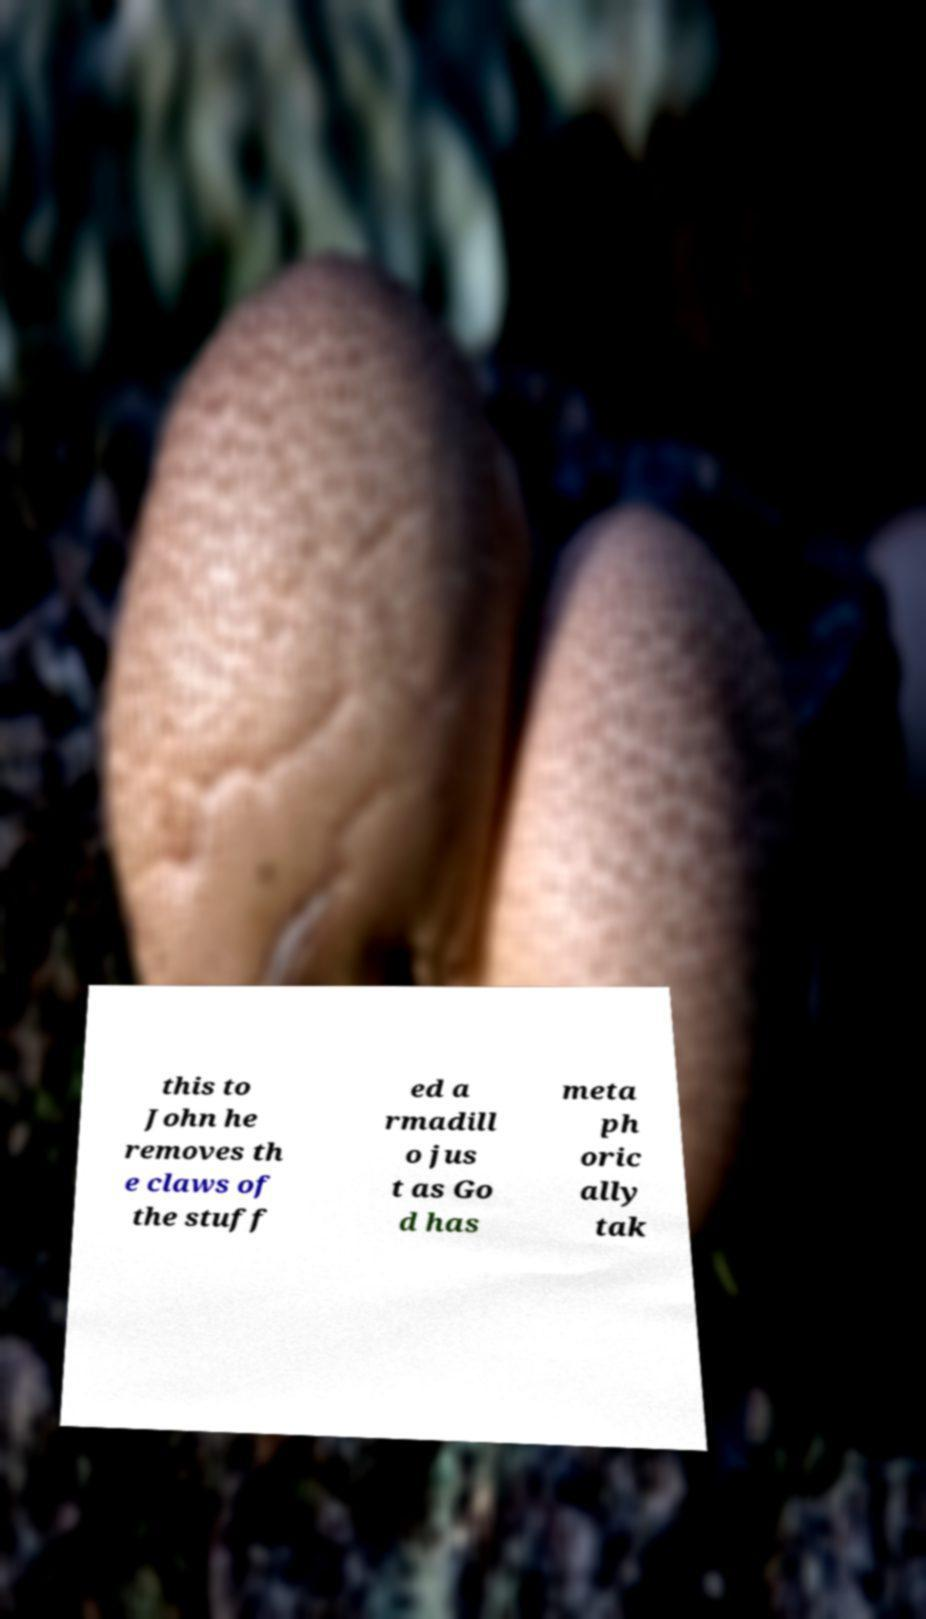What messages or text are displayed in this image? I need them in a readable, typed format. this to John he removes th e claws of the stuff ed a rmadill o jus t as Go d has meta ph oric ally tak 